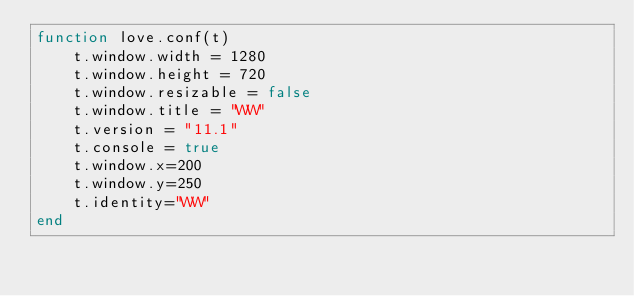<code> <loc_0><loc_0><loc_500><loc_500><_Lua_>function love.conf(t)
	t.window.width = 1280
	t.window.height = 720
	t.window.resizable = false
	t.window.title = "WW" 
	t.version = "11.1"
	t.console = true
	t.window.x=200
	t.window.y=250
	t.identity="WW"
end</code> 